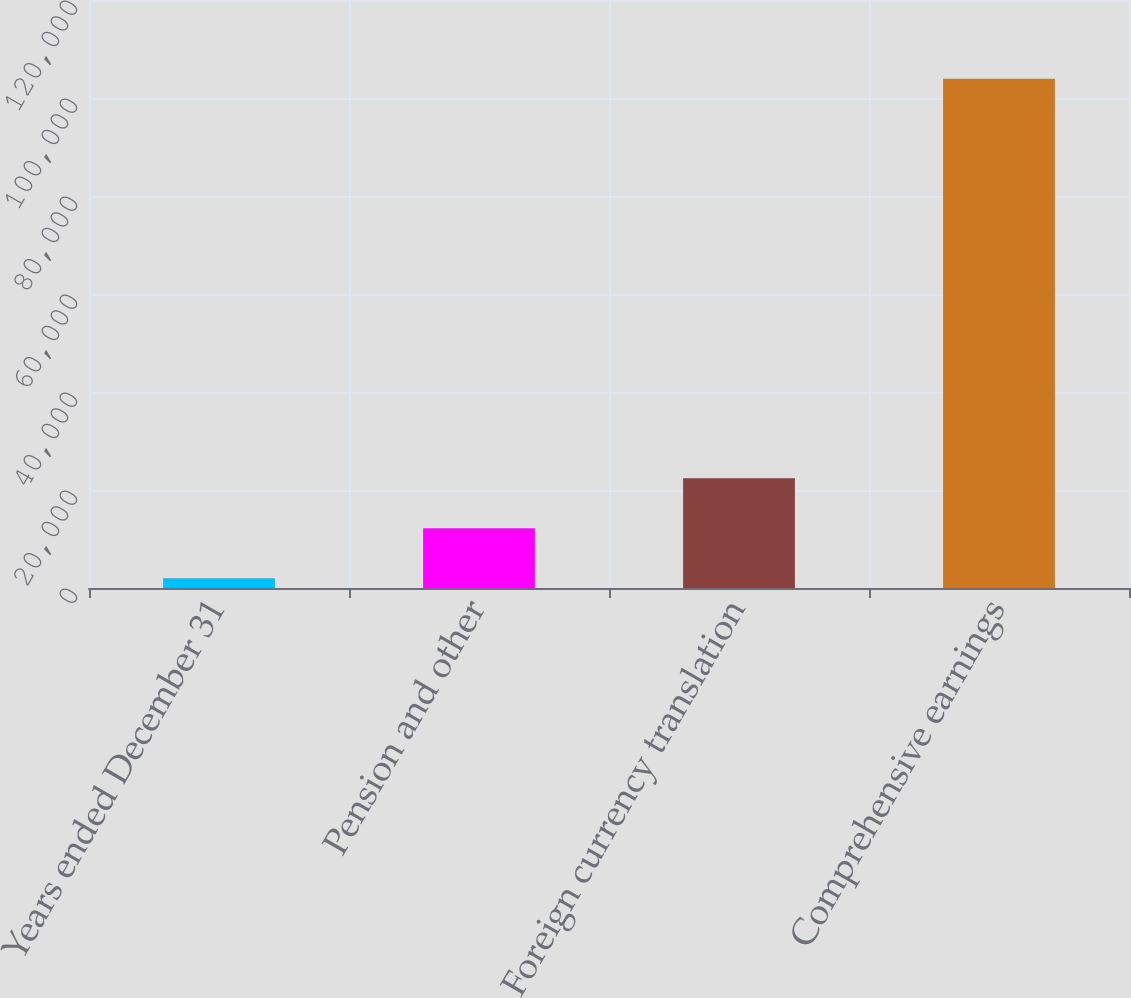<chart> <loc_0><loc_0><loc_500><loc_500><bar_chart><fcel>Years ended December 31<fcel>Pension and other<fcel>Foreign currency translation<fcel>Comprehensive earnings<nl><fcel>2015<fcel>12208.2<fcel>22401.4<fcel>103947<nl></chart> 